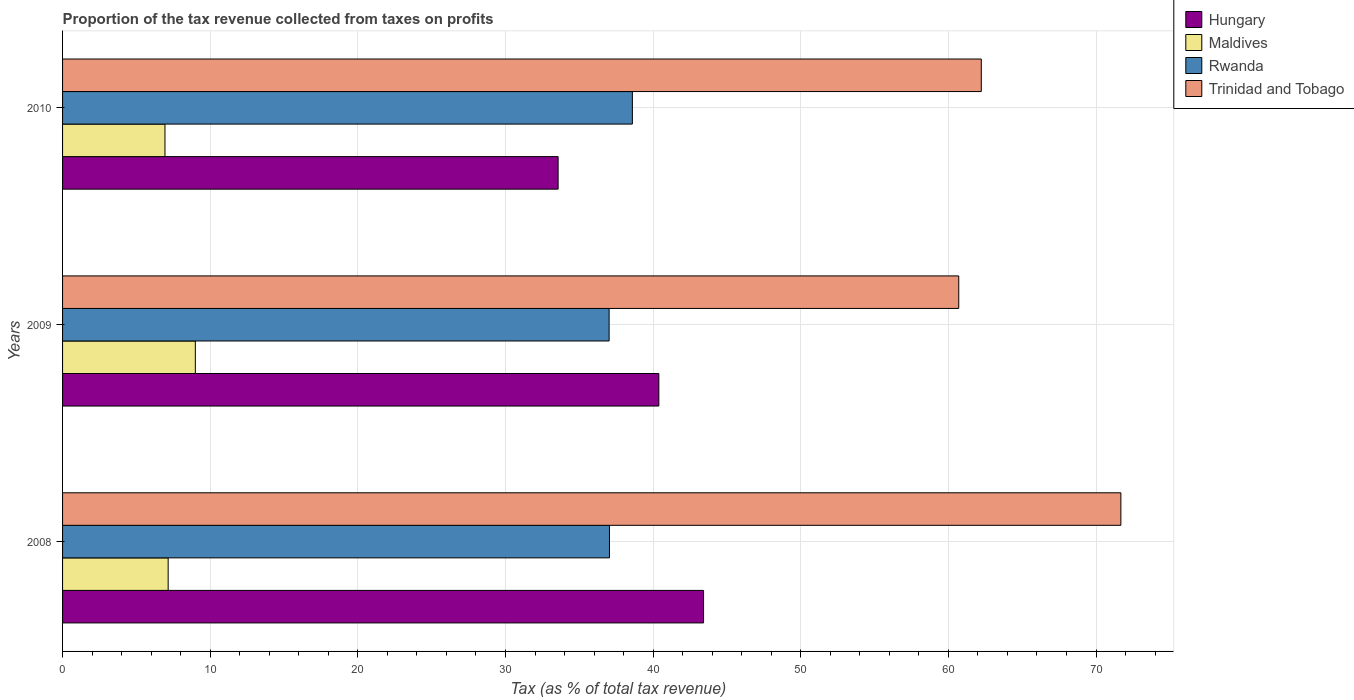How many different coloured bars are there?
Provide a succinct answer. 4. How many groups of bars are there?
Ensure brevity in your answer.  3. Are the number of bars per tick equal to the number of legend labels?
Your answer should be very brief. Yes. Are the number of bars on each tick of the Y-axis equal?
Provide a succinct answer. Yes. How many bars are there on the 2nd tick from the top?
Offer a terse response. 4. What is the label of the 2nd group of bars from the top?
Ensure brevity in your answer.  2009. In how many cases, is the number of bars for a given year not equal to the number of legend labels?
Keep it short and to the point. 0. What is the proportion of the tax revenue collected in Hungary in 2010?
Provide a succinct answer. 33.57. Across all years, what is the maximum proportion of the tax revenue collected in Maldives?
Offer a terse response. 8.99. Across all years, what is the minimum proportion of the tax revenue collected in Hungary?
Your answer should be very brief. 33.57. In which year was the proportion of the tax revenue collected in Trinidad and Tobago minimum?
Your answer should be very brief. 2009. What is the total proportion of the tax revenue collected in Hungary in the graph?
Provide a succinct answer. 117.37. What is the difference between the proportion of the tax revenue collected in Rwanda in 2008 and that in 2010?
Your response must be concise. -1.55. What is the difference between the proportion of the tax revenue collected in Trinidad and Tobago in 2009 and the proportion of the tax revenue collected in Hungary in 2008?
Your answer should be compact. 17.28. What is the average proportion of the tax revenue collected in Rwanda per year?
Offer a terse response. 37.55. In the year 2009, what is the difference between the proportion of the tax revenue collected in Maldives and proportion of the tax revenue collected in Hungary?
Give a very brief answer. -31.4. In how many years, is the proportion of the tax revenue collected in Maldives greater than 36 %?
Provide a short and direct response. 0. What is the ratio of the proportion of the tax revenue collected in Trinidad and Tobago in 2009 to that in 2010?
Ensure brevity in your answer.  0.98. Is the difference between the proportion of the tax revenue collected in Maldives in 2008 and 2009 greater than the difference between the proportion of the tax revenue collected in Hungary in 2008 and 2009?
Provide a succinct answer. No. What is the difference between the highest and the second highest proportion of the tax revenue collected in Trinidad and Tobago?
Provide a short and direct response. 9.45. What is the difference between the highest and the lowest proportion of the tax revenue collected in Rwanda?
Your answer should be compact. 1.58. Is the sum of the proportion of the tax revenue collected in Maldives in 2008 and 2010 greater than the maximum proportion of the tax revenue collected in Rwanda across all years?
Your answer should be compact. No. Is it the case that in every year, the sum of the proportion of the tax revenue collected in Trinidad and Tobago and proportion of the tax revenue collected in Rwanda is greater than the sum of proportion of the tax revenue collected in Hungary and proportion of the tax revenue collected in Maldives?
Your answer should be compact. Yes. What does the 3rd bar from the top in 2008 represents?
Ensure brevity in your answer.  Maldives. What does the 3rd bar from the bottom in 2009 represents?
Your response must be concise. Rwanda. How many years are there in the graph?
Your answer should be compact. 3. What is the difference between two consecutive major ticks on the X-axis?
Provide a short and direct response. 10. Where does the legend appear in the graph?
Give a very brief answer. Top right. How many legend labels are there?
Make the answer very short. 4. How are the legend labels stacked?
Provide a succinct answer. Vertical. What is the title of the graph?
Your answer should be very brief. Proportion of the tax revenue collected from taxes on profits. Does "Greenland" appear as one of the legend labels in the graph?
Make the answer very short. No. What is the label or title of the X-axis?
Ensure brevity in your answer.  Tax (as % of total tax revenue). What is the Tax (as % of total tax revenue) of Hungary in 2008?
Ensure brevity in your answer.  43.42. What is the Tax (as % of total tax revenue) of Maldives in 2008?
Offer a very short reply. 7.15. What is the Tax (as % of total tax revenue) of Rwanda in 2008?
Keep it short and to the point. 37.04. What is the Tax (as % of total tax revenue) in Trinidad and Tobago in 2008?
Ensure brevity in your answer.  71.68. What is the Tax (as % of total tax revenue) in Hungary in 2009?
Offer a very short reply. 40.39. What is the Tax (as % of total tax revenue) of Maldives in 2009?
Provide a short and direct response. 8.99. What is the Tax (as % of total tax revenue) in Rwanda in 2009?
Your response must be concise. 37.02. What is the Tax (as % of total tax revenue) of Trinidad and Tobago in 2009?
Keep it short and to the point. 60.7. What is the Tax (as % of total tax revenue) of Hungary in 2010?
Provide a short and direct response. 33.57. What is the Tax (as % of total tax revenue) in Maldives in 2010?
Make the answer very short. 6.94. What is the Tax (as % of total tax revenue) of Rwanda in 2010?
Offer a terse response. 38.6. What is the Tax (as % of total tax revenue) of Trinidad and Tobago in 2010?
Make the answer very short. 62.23. Across all years, what is the maximum Tax (as % of total tax revenue) in Hungary?
Offer a terse response. 43.42. Across all years, what is the maximum Tax (as % of total tax revenue) in Maldives?
Offer a terse response. 8.99. Across all years, what is the maximum Tax (as % of total tax revenue) in Rwanda?
Offer a very short reply. 38.6. Across all years, what is the maximum Tax (as % of total tax revenue) in Trinidad and Tobago?
Your answer should be compact. 71.68. Across all years, what is the minimum Tax (as % of total tax revenue) in Hungary?
Offer a terse response. 33.57. Across all years, what is the minimum Tax (as % of total tax revenue) of Maldives?
Ensure brevity in your answer.  6.94. Across all years, what is the minimum Tax (as % of total tax revenue) in Rwanda?
Your answer should be compact. 37.02. Across all years, what is the minimum Tax (as % of total tax revenue) in Trinidad and Tobago?
Your answer should be compact. 60.7. What is the total Tax (as % of total tax revenue) of Hungary in the graph?
Provide a short and direct response. 117.37. What is the total Tax (as % of total tax revenue) in Maldives in the graph?
Your answer should be compact. 23.08. What is the total Tax (as % of total tax revenue) of Rwanda in the graph?
Give a very brief answer. 112.66. What is the total Tax (as % of total tax revenue) of Trinidad and Tobago in the graph?
Ensure brevity in your answer.  194.61. What is the difference between the Tax (as % of total tax revenue) of Hungary in 2008 and that in 2009?
Provide a succinct answer. 3.03. What is the difference between the Tax (as % of total tax revenue) in Maldives in 2008 and that in 2009?
Ensure brevity in your answer.  -1.84. What is the difference between the Tax (as % of total tax revenue) in Rwanda in 2008 and that in 2009?
Offer a very short reply. 0.02. What is the difference between the Tax (as % of total tax revenue) in Trinidad and Tobago in 2008 and that in 2009?
Provide a succinct answer. 10.98. What is the difference between the Tax (as % of total tax revenue) of Hungary in 2008 and that in 2010?
Your answer should be compact. 9.85. What is the difference between the Tax (as % of total tax revenue) in Maldives in 2008 and that in 2010?
Offer a terse response. 0.22. What is the difference between the Tax (as % of total tax revenue) of Rwanda in 2008 and that in 2010?
Provide a short and direct response. -1.55. What is the difference between the Tax (as % of total tax revenue) in Trinidad and Tobago in 2008 and that in 2010?
Ensure brevity in your answer.  9.45. What is the difference between the Tax (as % of total tax revenue) of Hungary in 2009 and that in 2010?
Make the answer very short. 6.82. What is the difference between the Tax (as % of total tax revenue) of Maldives in 2009 and that in 2010?
Provide a short and direct response. 2.06. What is the difference between the Tax (as % of total tax revenue) in Rwanda in 2009 and that in 2010?
Ensure brevity in your answer.  -1.58. What is the difference between the Tax (as % of total tax revenue) of Trinidad and Tobago in 2009 and that in 2010?
Provide a succinct answer. -1.53. What is the difference between the Tax (as % of total tax revenue) of Hungary in 2008 and the Tax (as % of total tax revenue) of Maldives in 2009?
Offer a terse response. 34.42. What is the difference between the Tax (as % of total tax revenue) of Hungary in 2008 and the Tax (as % of total tax revenue) of Rwanda in 2009?
Provide a succinct answer. 6.4. What is the difference between the Tax (as % of total tax revenue) in Hungary in 2008 and the Tax (as % of total tax revenue) in Trinidad and Tobago in 2009?
Ensure brevity in your answer.  -17.28. What is the difference between the Tax (as % of total tax revenue) in Maldives in 2008 and the Tax (as % of total tax revenue) in Rwanda in 2009?
Keep it short and to the point. -29.87. What is the difference between the Tax (as % of total tax revenue) of Maldives in 2008 and the Tax (as % of total tax revenue) of Trinidad and Tobago in 2009?
Make the answer very short. -53.55. What is the difference between the Tax (as % of total tax revenue) in Rwanda in 2008 and the Tax (as % of total tax revenue) in Trinidad and Tobago in 2009?
Keep it short and to the point. -23.66. What is the difference between the Tax (as % of total tax revenue) in Hungary in 2008 and the Tax (as % of total tax revenue) in Maldives in 2010?
Provide a succinct answer. 36.48. What is the difference between the Tax (as % of total tax revenue) of Hungary in 2008 and the Tax (as % of total tax revenue) of Rwanda in 2010?
Ensure brevity in your answer.  4.82. What is the difference between the Tax (as % of total tax revenue) of Hungary in 2008 and the Tax (as % of total tax revenue) of Trinidad and Tobago in 2010?
Your response must be concise. -18.81. What is the difference between the Tax (as % of total tax revenue) in Maldives in 2008 and the Tax (as % of total tax revenue) in Rwanda in 2010?
Your answer should be very brief. -31.44. What is the difference between the Tax (as % of total tax revenue) of Maldives in 2008 and the Tax (as % of total tax revenue) of Trinidad and Tobago in 2010?
Offer a terse response. -55.08. What is the difference between the Tax (as % of total tax revenue) of Rwanda in 2008 and the Tax (as % of total tax revenue) of Trinidad and Tobago in 2010?
Provide a succinct answer. -25.19. What is the difference between the Tax (as % of total tax revenue) in Hungary in 2009 and the Tax (as % of total tax revenue) in Maldives in 2010?
Offer a very short reply. 33.45. What is the difference between the Tax (as % of total tax revenue) of Hungary in 2009 and the Tax (as % of total tax revenue) of Rwanda in 2010?
Offer a very short reply. 1.79. What is the difference between the Tax (as % of total tax revenue) of Hungary in 2009 and the Tax (as % of total tax revenue) of Trinidad and Tobago in 2010?
Your answer should be compact. -21.84. What is the difference between the Tax (as % of total tax revenue) of Maldives in 2009 and the Tax (as % of total tax revenue) of Rwanda in 2010?
Provide a succinct answer. -29.6. What is the difference between the Tax (as % of total tax revenue) in Maldives in 2009 and the Tax (as % of total tax revenue) in Trinidad and Tobago in 2010?
Provide a short and direct response. -53.24. What is the difference between the Tax (as % of total tax revenue) in Rwanda in 2009 and the Tax (as % of total tax revenue) in Trinidad and Tobago in 2010?
Give a very brief answer. -25.21. What is the average Tax (as % of total tax revenue) in Hungary per year?
Ensure brevity in your answer.  39.12. What is the average Tax (as % of total tax revenue) in Maldives per year?
Your answer should be very brief. 7.69. What is the average Tax (as % of total tax revenue) of Rwanda per year?
Offer a very short reply. 37.55. What is the average Tax (as % of total tax revenue) in Trinidad and Tobago per year?
Keep it short and to the point. 64.87. In the year 2008, what is the difference between the Tax (as % of total tax revenue) of Hungary and Tax (as % of total tax revenue) of Maldives?
Provide a succinct answer. 36.27. In the year 2008, what is the difference between the Tax (as % of total tax revenue) of Hungary and Tax (as % of total tax revenue) of Rwanda?
Offer a terse response. 6.37. In the year 2008, what is the difference between the Tax (as % of total tax revenue) of Hungary and Tax (as % of total tax revenue) of Trinidad and Tobago?
Your response must be concise. -28.27. In the year 2008, what is the difference between the Tax (as % of total tax revenue) in Maldives and Tax (as % of total tax revenue) in Rwanda?
Your response must be concise. -29.89. In the year 2008, what is the difference between the Tax (as % of total tax revenue) in Maldives and Tax (as % of total tax revenue) in Trinidad and Tobago?
Your answer should be very brief. -64.53. In the year 2008, what is the difference between the Tax (as % of total tax revenue) of Rwanda and Tax (as % of total tax revenue) of Trinidad and Tobago?
Make the answer very short. -34.64. In the year 2009, what is the difference between the Tax (as % of total tax revenue) of Hungary and Tax (as % of total tax revenue) of Maldives?
Your answer should be compact. 31.4. In the year 2009, what is the difference between the Tax (as % of total tax revenue) in Hungary and Tax (as % of total tax revenue) in Rwanda?
Your answer should be compact. 3.37. In the year 2009, what is the difference between the Tax (as % of total tax revenue) in Hungary and Tax (as % of total tax revenue) in Trinidad and Tobago?
Your response must be concise. -20.31. In the year 2009, what is the difference between the Tax (as % of total tax revenue) of Maldives and Tax (as % of total tax revenue) of Rwanda?
Give a very brief answer. -28.03. In the year 2009, what is the difference between the Tax (as % of total tax revenue) of Maldives and Tax (as % of total tax revenue) of Trinidad and Tobago?
Your answer should be very brief. -51.71. In the year 2009, what is the difference between the Tax (as % of total tax revenue) in Rwanda and Tax (as % of total tax revenue) in Trinidad and Tobago?
Keep it short and to the point. -23.68. In the year 2010, what is the difference between the Tax (as % of total tax revenue) in Hungary and Tax (as % of total tax revenue) in Maldives?
Your response must be concise. 26.63. In the year 2010, what is the difference between the Tax (as % of total tax revenue) of Hungary and Tax (as % of total tax revenue) of Rwanda?
Give a very brief answer. -5.03. In the year 2010, what is the difference between the Tax (as % of total tax revenue) in Hungary and Tax (as % of total tax revenue) in Trinidad and Tobago?
Offer a very short reply. -28.66. In the year 2010, what is the difference between the Tax (as % of total tax revenue) of Maldives and Tax (as % of total tax revenue) of Rwanda?
Offer a very short reply. -31.66. In the year 2010, what is the difference between the Tax (as % of total tax revenue) in Maldives and Tax (as % of total tax revenue) in Trinidad and Tobago?
Offer a very short reply. -55.29. In the year 2010, what is the difference between the Tax (as % of total tax revenue) of Rwanda and Tax (as % of total tax revenue) of Trinidad and Tobago?
Your answer should be compact. -23.63. What is the ratio of the Tax (as % of total tax revenue) in Hungary in 2008 to that in 2009?
Make the answer very short. 1.07. What is the ratio of the Tax (as % of total tax revenue) of Maldives in 2008 to that in 2009?
Give a very brief answer. 0.8. What is the ratio of the Tax (as % of total tax revenue) of Rwanda in 2008 to that in 2009?
Your response must be concise. 1. What is the ratio of the Tax (as % of total tax revenue) of Trinidad and Tobago in 2008 to that in 2009?
Your answer should be compact. 1.18. What is the ratio of the Tax (as % of total tax revenue) in Hungary in 2008 to that in 2010?
Your answer should be compact. 1.29. What is the ratio of the Tax (as % of total tax revenue) of Maldives in 2008 to that in 2010?
Ensure brevity in your answer.  1.03. What is the ratio of the Tax (as % of total tax revenue) in Rwanda in 2008 to that in 2010?
Provide a short and direct response. 0.96. What is the ratio of the Tax (as % of total tax revenue) in Trinidad and Tobago in 2008 to that in 2010?
Provide a succinct answer. 1.15. What is the ratio of the Tax (as % of total tax revenue) in Hungary in 2009 to that in 2010?
Offer a terse response. 1.2. What is the ratio of the Tax (as % of total tax revenue) of Maldives in 2009 to that in 2010?
Keep it short and to the point. 1.3. What is the ratio of the Tax (as % of total tax revenue) in Rwanda in 2009 to that in 2010?
Provide a short and direct response. 0.96. What is the ratio of the Tax (as % of total tax revenue) in Trinidad and Tobago in 2009 to that in 2010?
Keep it short and to the point. 0.98. What is the difference between the highest and the second highest Tax (as % of total tax revenue) in Hungary?
Provide a short and direct response. 3.03. What is the difference between the highest and the second highest Tax (as % of total tax revenue) of Maldives?
Your response must be concise. 1.84. What is the difference between the highest and the second highest Tax (as % of total tax revenue) of Rwanda?
Make the answer very short. 1.55. What is the difference between the highest and the second highest Tax (as % of total tax revenue) in Trinidad and Tobago?
Your answer should be compact. 9.45. What is the difference between the highest and the lowest Tax (as % of total tax revenue) in Hungary?
Your answer should be compact. 9.85. What is the difference between the highest and the lowest Tax (as % of total tax revenue) of Maldives?
Make the answer very short. 2.06. What is the difference between the highest and the lowest Tax (as % of total tax revenue) of Rwanda?
Provide a succinct answer. 1.58. What is the difference between the highest and the lowest Tax (as % of total tax revenue) in Trinidad and Tobago?
Keep it short and to the point. 10.98. 